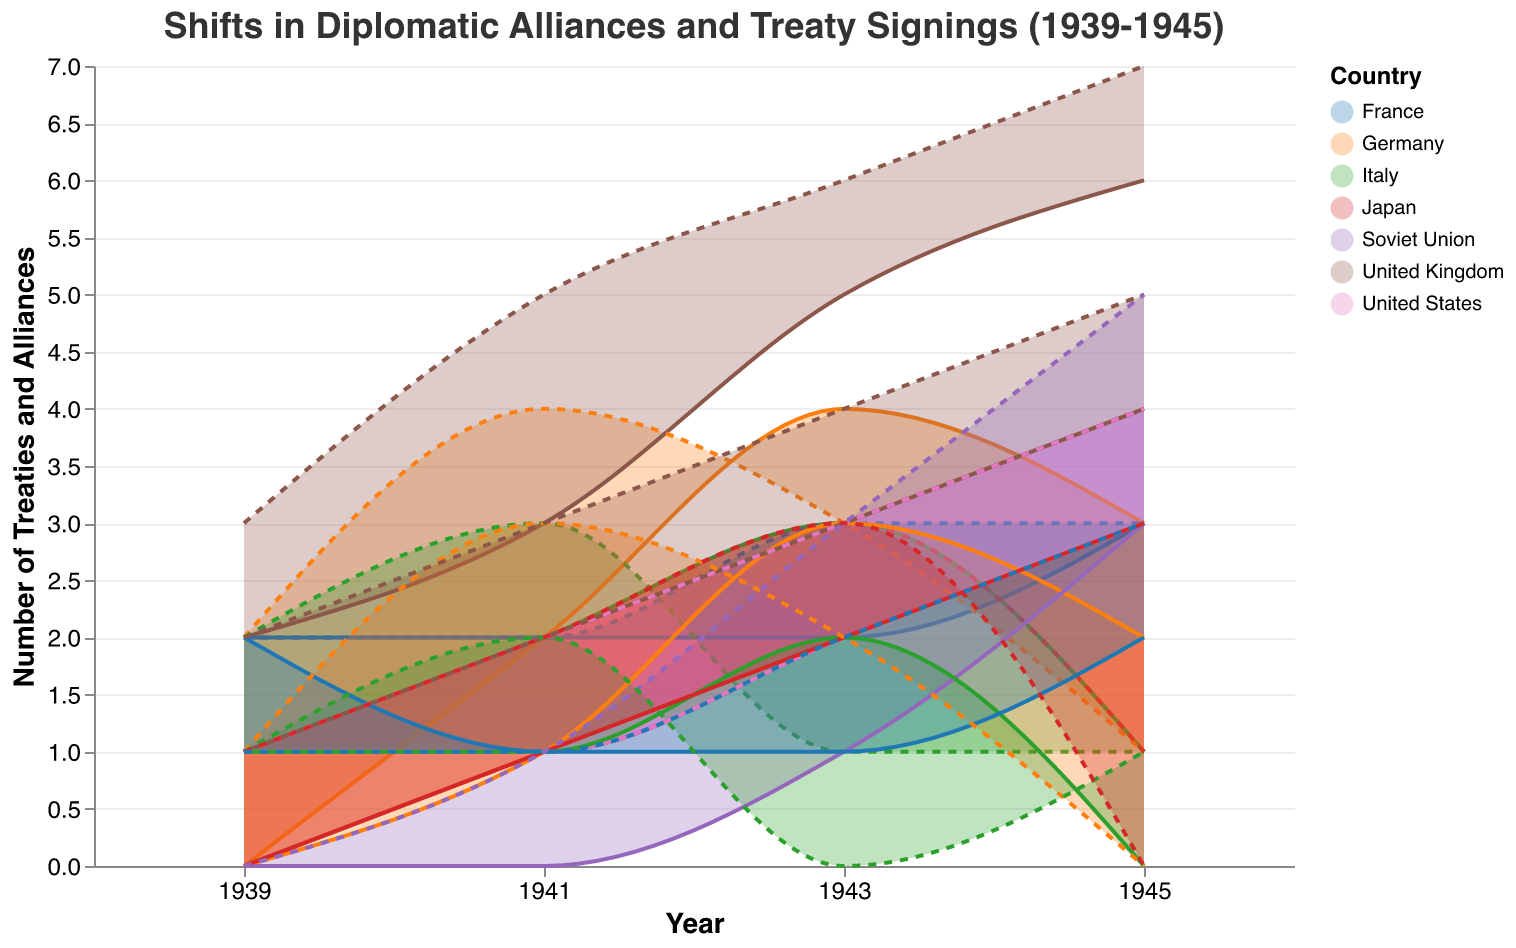How many treaties had the United Kingdom signed by the end of 1945? According to the range area chart, the "EndTreaties" value for the United Kingdom in 1945 is 7.
Answer: 7 Which country had the largest increase in alliances from 1939 to 1945? By reviewing the "StartAlliances" and "EndAlliances" data for each country from 1939 to 1945, the Soviet Union showed the most significant increase in alliances, from 0 to 5.
Answer: Soviet Union How did Germany’s number of treaties change from 1943 to 1945? From the chart, Germany had 3 treaties in 1943 which reduced to 1 by 1945. This represents a decrease.
Answer: Decreased Compare the number of alliances Italy had in 1941 with Germany in the same year. Which one had more? In 1941, Italy had 2 alliances, while Germany had 3. Thus, Germany had more alliances.
Answer: Germany Which country had no change in the number of treaties between 1939 and 1941? The United States had 1 treaty in both 1939 and 1941, indicating no change.
Answer: United States Among the listed countries, which showed a decrease in the number of alliances towards the last recorded year? The chart shows that Germany, Italy, and Japan each had fewer alliances in 1945 than in 1943.
Answer: Germany, Italy, Japan In which year did Japan have the highest number of treaties? Reviewing Japan's data in the chart, the year 1943 had the highest number of treaties with a value of 3.
Answer: 1943 Which country had the most stable number of treaties throughout the period 1939-1945? Observing the stability of treaties over the years, the United States had a steadily increasing number of treaties with no sharp fluctuations.
Answer: United States How many alliances did France hold in 1939 compared to 1941? France had 2 alliances in 1939 and then reduced to 1 in 1941, indicating a decrease of 1 alliance.
Answer: Decreased by 1 